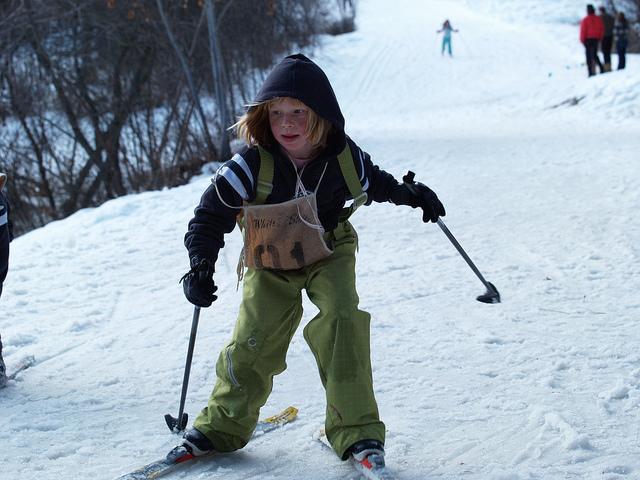Does this person seem like an experienced skier?
Be succinct. No. What is on the person's foot?
Keep it brief. Skis. Is the person enjoying himself?
Give a very brief answer. Yes. What is the person holding?
Short answer required. Ski poles. 